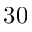Convert formula to latex. <formula><loc_0><loc_0><loc_500><loc_500>3 0</formula> 